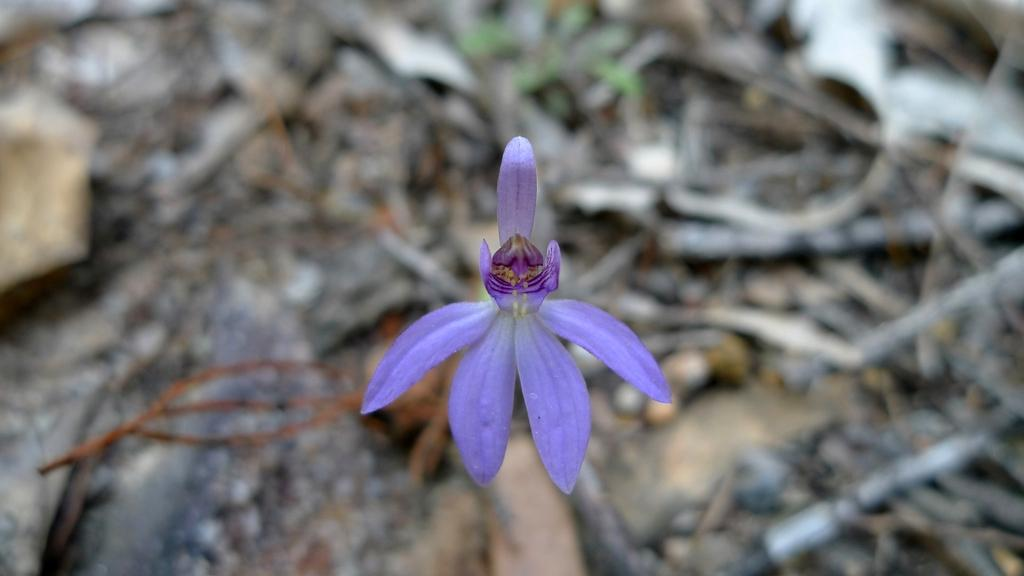What type of flower can be seen in the image? There is a violet color flower in the image. What can be observed on the ground in the background of the image? There are many sticks and stones on the ground in the background of the image. What type of horn can be seen on the basketball player in the image? There is no basketball player or horn present in the image; it features a violet color flower and sticks and stones on the ground. Where is the school located in the image? There is no school present in the image; it features a violet color flower and sticks and stones on the ground. 